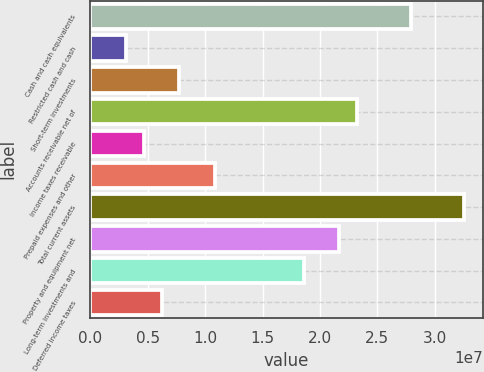<chart> <loc_0><loc_0><loc_500><loc_500><bar_chart><fcel>Cash and cash equivalents<fcel>Restricted cash and cash<fcel>Short-term investments<fcel>Accounts receivable net of<fcel>Income taxes receivable<fcel>Prepaid expenses and other<fcel>Total current assets<fcel>Property and equipment net<fcel>Long-term investments and<fcel>Deferred income taxes<nl><fcel>2.79069e+07<fcel>3.10076e+06<fcel>7.75191e+06<fcel>2.32557e+07<fcel>4.65114e+06<fcel>1.08527e+07<fcel>3.2558e+07<fcel>2.17053e+07<fcel>1.86046e+07<fcel>6.20153e+06<nl></chart> 